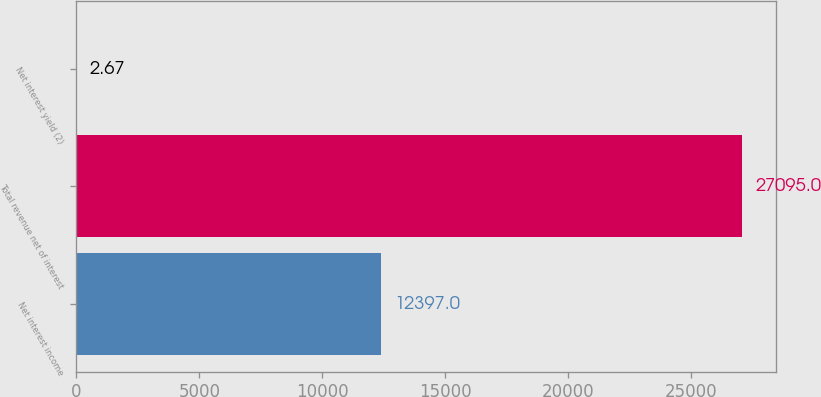Convert chart to OTSL. <chart><loc_0><loc_0><loc_500><loc_500><bar_chart><fcel>Net interest income<fcel>Total revenue net of interest<fcel>Net interest yield (2)<nl><fcel>12397<fcel>27095<fcel>2.67<nl></chart> 